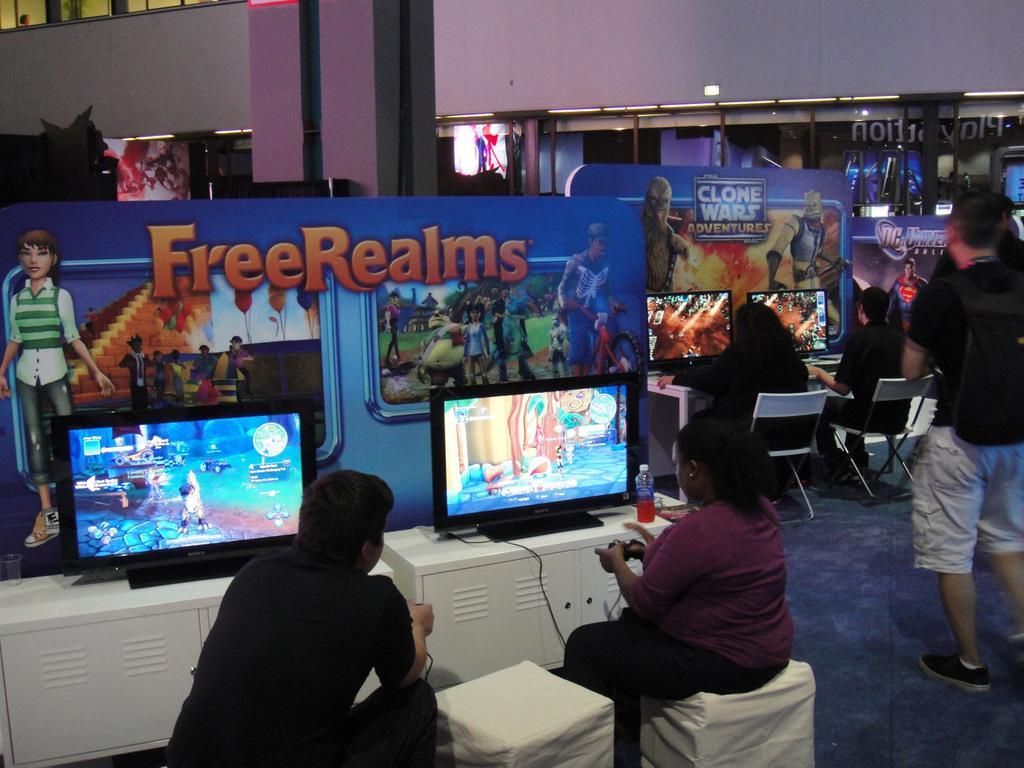How would you summarize this image in a sentence or two? In this picture we can see a group of people on the ground, here we can see chairs, monitors, cartoon boards, wall and some objects. 